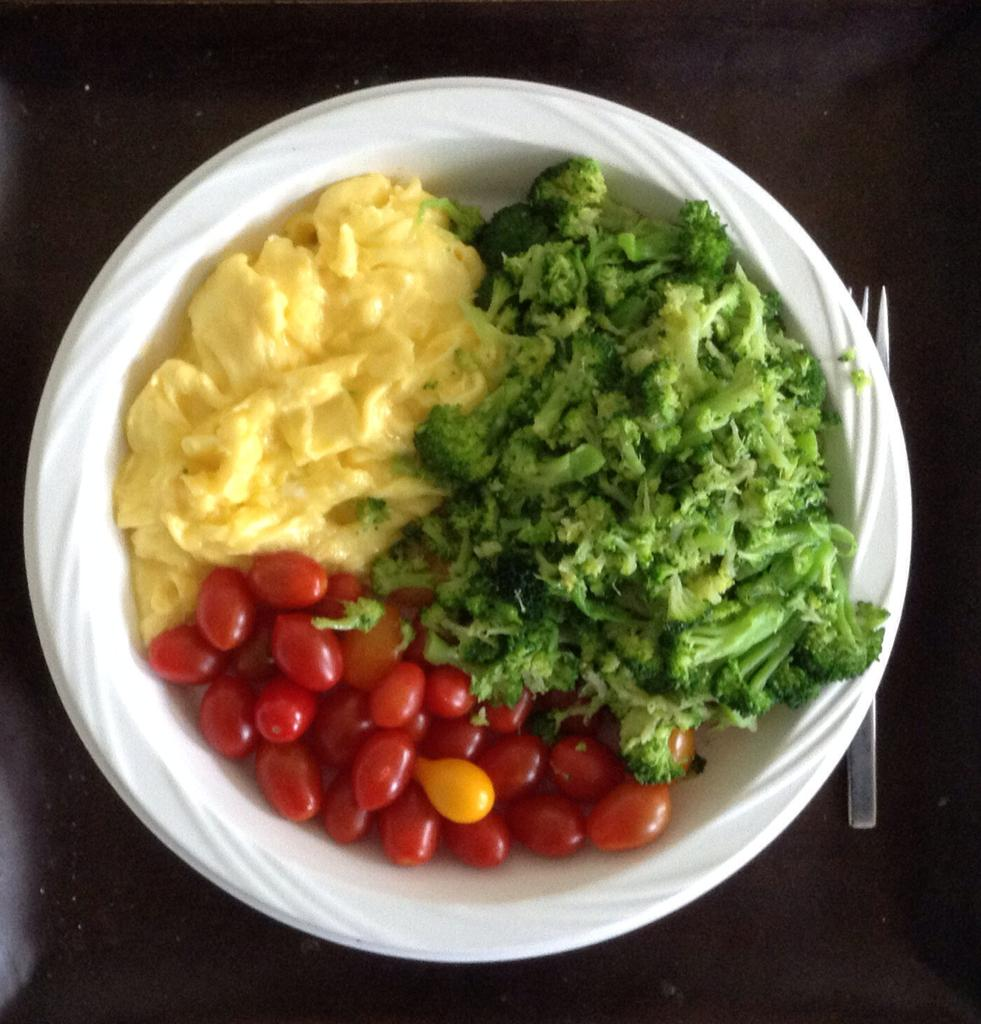What type of container holds the food items in the image? The food items are in a paper bowl. What utensil is present on the table in the image? A fork is visible on the table. How many strings are attached to the food items in the image? There are no strings attached to the food items in the image. What type of fruit can be seen mixed with the food items in the image? There is no fruit, such as cherries, present in the image. 